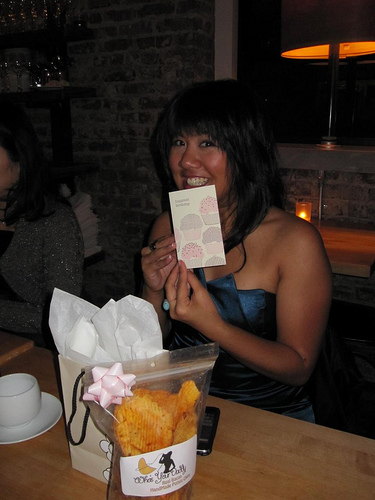<image>
Can you confirm if the chips is on the girl? No. The chips is not positioned on the girl. They may be near each other, but the chips is not supported by or resting on top of the girl. Is the lamp in front of the person? No. The lamp is not in front of the person. The spatial positioning shows a different relationship between these objects. 